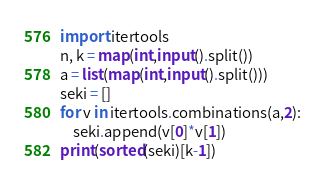Convert code to text. <code><loc_0><loc_0><loc_500><loc_500><_Python_>import itertools
n, k = map(int,input().split())
a = list(map(int,input().split()))
seki = []
for v in itertools.combinations(a,2):
    seki.append(v[0]*v[1])
print(sorted(seki)[k-1])


</code> 